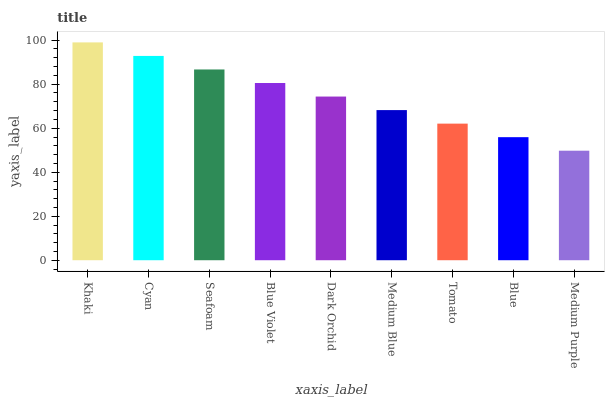Is Medium Purple the minimum?
Answer yes or no. Yes. Is Khaki the maximum?
Answer yes or no. Yes. Is Cyan the minimum?
Answer yes or no. No. Is Cyan the maximum?
Answer yes or no. No. Is Khaki greater than Cyan?
Answer yes or no. Yes. Is Cyan less than Khaki?
Answer yes or no. Yes. Is Cyan greater than Khaki?
Answer yes or no. No. Is Khaki less than Cyan?
Answer yes or no. No. Is Dark Orchid the high median?
Answer yes or no. Yes. Is Dark Orchid the low median?
Answer yes or no. Yes. Is Tomato the high median?
Answer yes or no. No. Is Cyan the low median?
Answer yes or no. No. 